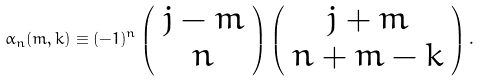Convert formula to latex. <formula><loc_0><loc_0><loc_500><loc_500>\alpha _ { n } ( m , k ) \equiv ( - 1 ) ^ { n } \left ( \begin{array} { c } j - m \\ n \end{array} \right ) \left ( \begin{array} { c } j + m \\ n + m - k \end{array} \right ) .</formula> 